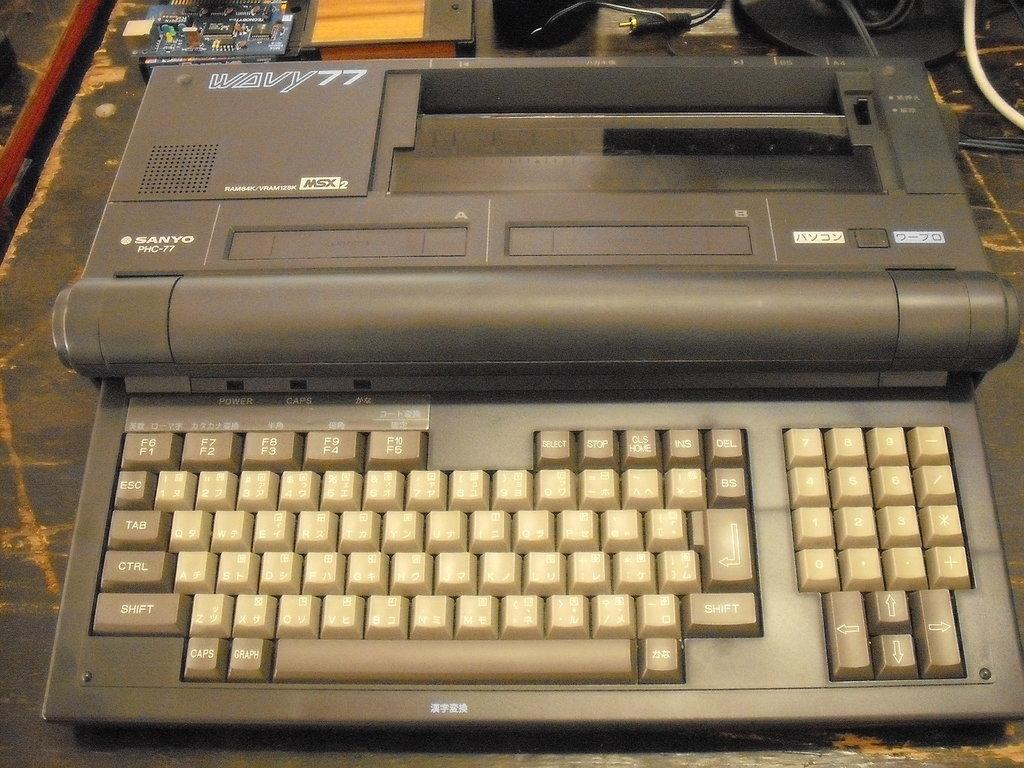<image>
Relay a brief, clear account of the picture shown. A brown and tan Wavy 77 by Sanyo portable typewriter 